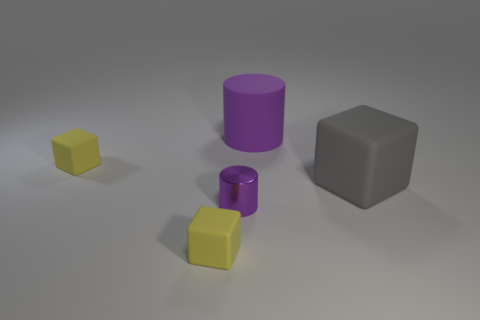Subtract all brown spheres. How many yellow blocks are left? 2 Subtract all tiny yellow blocks. How many blocks are left? 1 Add 2 small rubber cylinders. How many objects exist? 7 Subtract all small purple metal cylinders. Subtract all big gray matte blocks. How many objects are left? 3 Add 1 tiny yellow blocks. How many tiny yellow blocks are left? 3 Add 2 tiny yellow rubber cylinders. How many tiny yellow rubber cylinders exist? 2 Subtract 0 gray balls. How many objects are left? 5 Subtract all cubes. How many objects are left? 2 